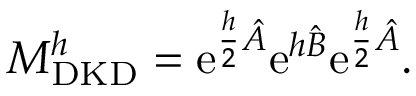Convert formula to latex. <formula><loc_0><loc_0><loc_500><loc_500>M _ { D K D } ^ { h } = e ^ { \frac { h } { 2 } \hat { A } } e ^ { h \hat { B } } e ^ { \frac { h } { 2 } \hat { A } } .</formula> 